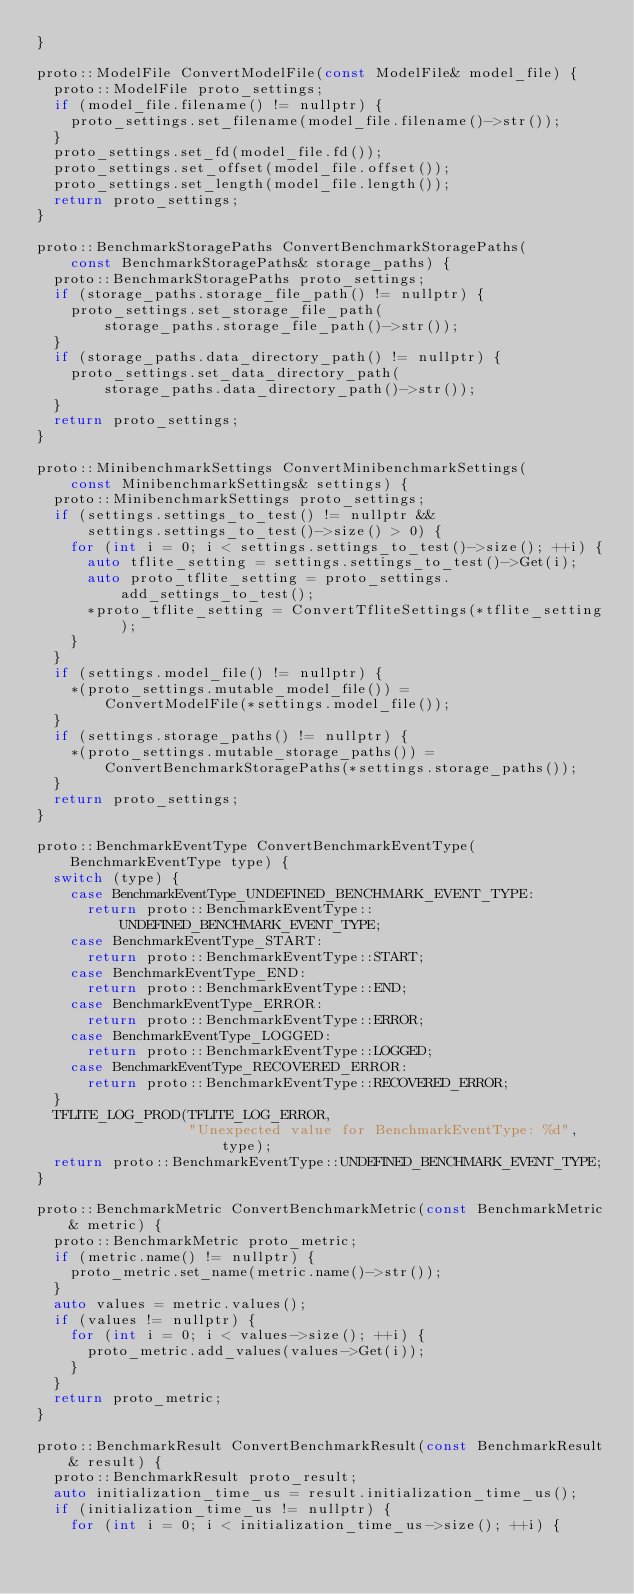Convert code to text. <code><loc_0><loc_0><loc_500><loc_500><_C++_>}

proto::ModelFile ConvertModelFile(const ModelFile& model_file) {
  proto::ModelFile proto_settings;
  if (model_file.filename() != nullptr) {
    proto_settings.set_filename(model_file.filename()->str());
  }
  proto_settings.set_fd(model_file.fd());
  proto_settings.set_offset(model_file.offset());
  proto_settings.set_length(model_file.length());
  return proto_settings;
}

proto::BenchmarkStoragePaths ConvertBenchmarkStoragePaths(
    const BenchmarkStoragePaths& storage_paths) {
  proto::BenchmarkStoragePaths proto_settings;
  if (storage_paths.storage_file_path() != nullptr) {
    proto_settings.set_storage_file_path(
        storage_paths.storage_file_path()->str());
  }
  if (storage_paths.data_directory_path() != nullptr) {
    proto_settings.set_data_directory_path(
        storage_paths.data_directory_path()->str());
  }
  return proto_settings;
}

proto::MinibenchmarkSettings ConvertMinibenchmarkSettings(
    const MinibenchmarkSettings& settings) {
  proto::MinibenchmarkSettings proto_settings;
  if (settings.settings_to_test() != nullptr &&
      settings.settings_to_test()->size() > 0) {
    for (int i = 0; i < settings.settings_to_test()->size(); ++i) {
      auto tflite_setting = settings.settings_to_test()->Get(i);
      auto proto_tflite_setting = proto_settings.add_settings_to_test();
      *proto_tflite_setting = ConvertTfliteSettings(*tflite_setting);
    }
  }
  if (settings.model_file() != nullptr) {
    *(proto_settings.mutable_model_file()) =
        ConvertModelFile(*settings.model_file());
  }
  if (settings.storage_paths() != nullptr) {
    *(proto_settings.mutable_storage_paths()) =
        ConvertBenchmarkStoragePaths(*settings.storage_paths());
  }
  return proto_settings;
}

proto::BenchmarkEventType ConvertBenchmarkEventType(BenchmarkEventType type) {
  switch (type) {
    case BenchmarkEventType_UNDEFINED_BENCHMARK_EVENT_TYPE:
      return proto::BenchmarkEventType::UNDEFINED_BENCHMARK_EVENT_TYPE;
    case BenchmarkEventType_START:
      return proto::BenchmarkEventType::START;
    case BenchmarkEventType_END:
      return proto::BenchmarkEventType::END;
    case BenchmarkEventType_ERROR:
      return proto::BenchmarkEventType::ERROR;
    case BenchmarkEventType_LOGGED:
      return proto::BenchmarkEventType::LOGGED;
    case BenchmarkEventType_RECOVERED_ERROR:
      return proto::BenchmarkEventType::RECOVERED_ERROR;
  }
  TFLITE_LOG_PROD(TFLITE_LOG_ERROR,
                  "Unexpected value for BenchmarkEventType: %d", type);
  return proto::BenchmarkEventType::UNDEFINED_BENCHMARK_EVENT_TYPE;
}

proto::BenchmarkMetric ConvertBenchmarkMetric(const BenchmarkMetric& metric) {
  proto::BenchmarkMetric proto_metric;
  if (metric.name() != nullptr) {
    proto_metric.set_name(metric.name()->str());
  }
  auto values = metric.values();
  if (values != nullptr) {
    for (int i = 0; i < values->size(); ++i) {
      proto_metric.add_values(values->Get(i));
    }
  }
  return proto_metric;
}

proto::BenchmarkResult ConvertBenchmarkResult(const BenchmarkResult& result) {
  proto::BenchmarkResult proto_result;
  auto initialization_time_us = result.initialization_time_us();
  if (initialization_time_us != nullptr) {
    for (int i = 0; i < initialization_time_us->size(); ++i) {</code> 